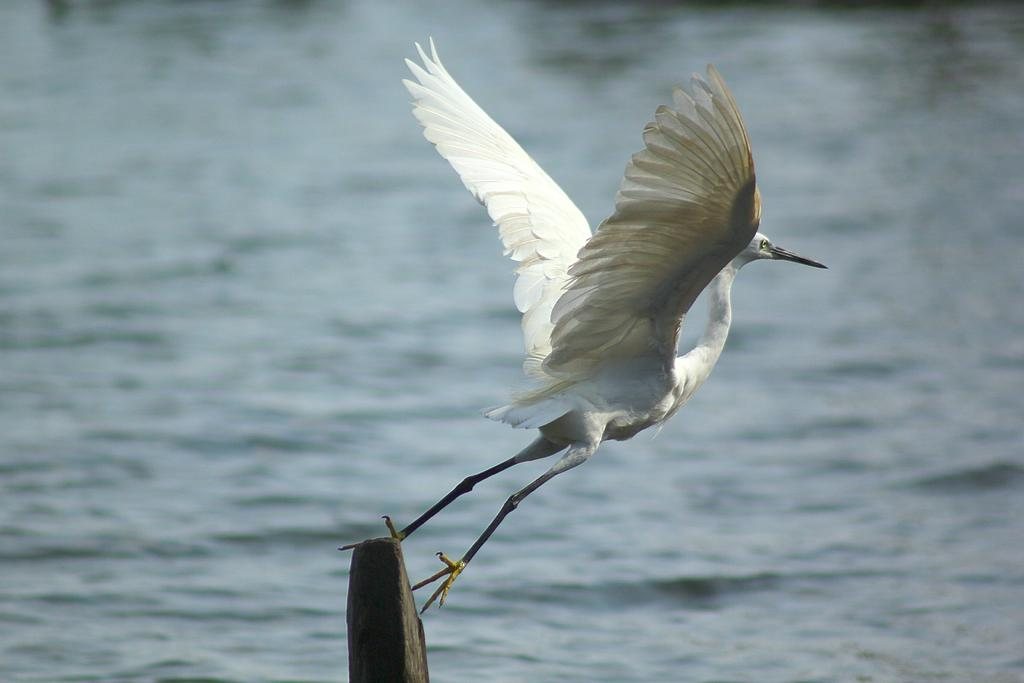What is the color of the object in the image? The object in the image is black. What is on top of the black object? There is a bird on the black object. What color is the bird? The bird is white in color. What can be seen in the background of the image? Water is visible in the background of the image. Can you see any stockings on the bird in the image? There are no stockings present on the bird in the image. Is there an apple on the black object next to the bird? There is no apple visible in the image; only the bird is present on the black object. 